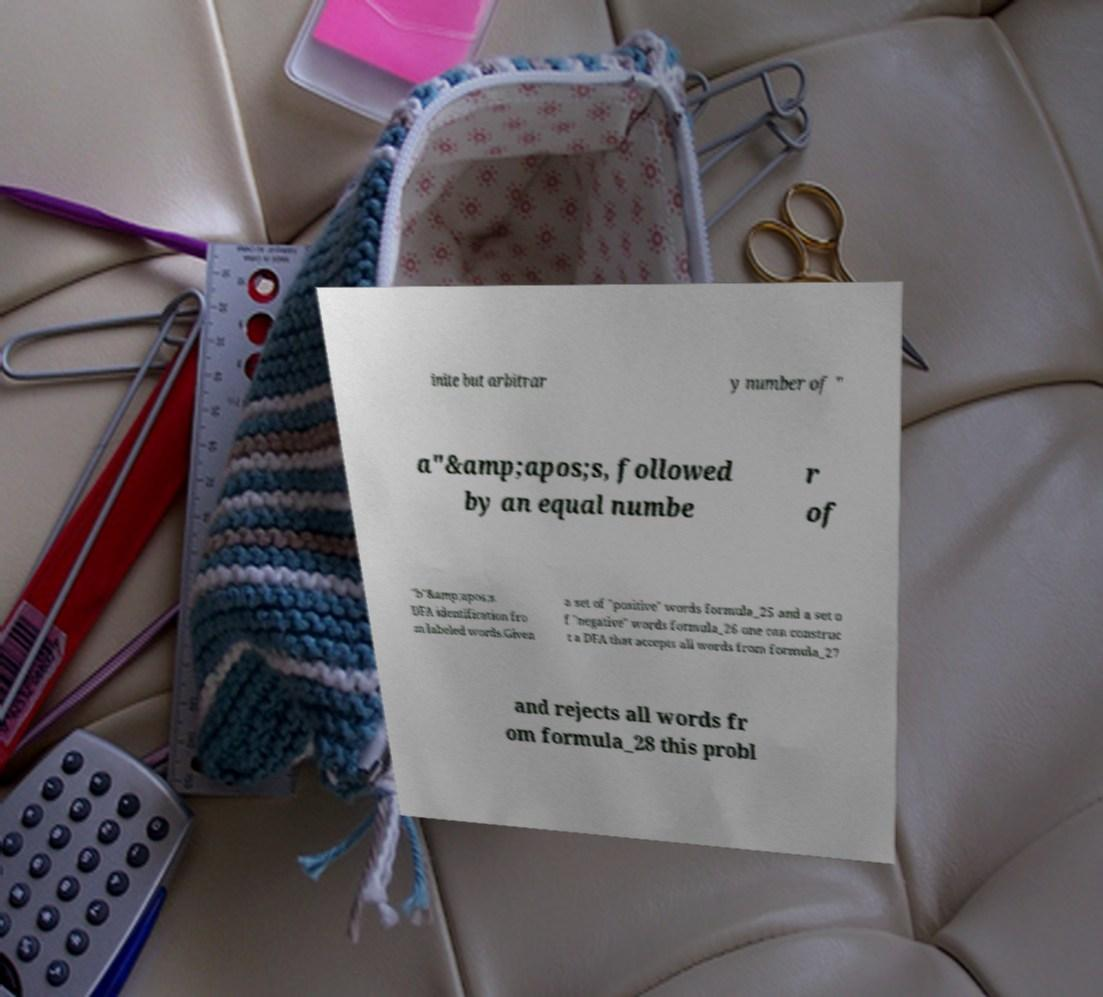What messages or text are displayed in this image? I need them in a readable, typed format. inite but arbitrar y number of " a"&amp;apos;s, followed by an equal numbe r of "b"&amp;apos;s. DFA identification fro m labeled words.Given a set of "positive" words formula_25 and a set o f "negative" words formula_26 one can construc t a DFA that accepts all words from formula_27 and rejects all words fr om formula_28 this probl 